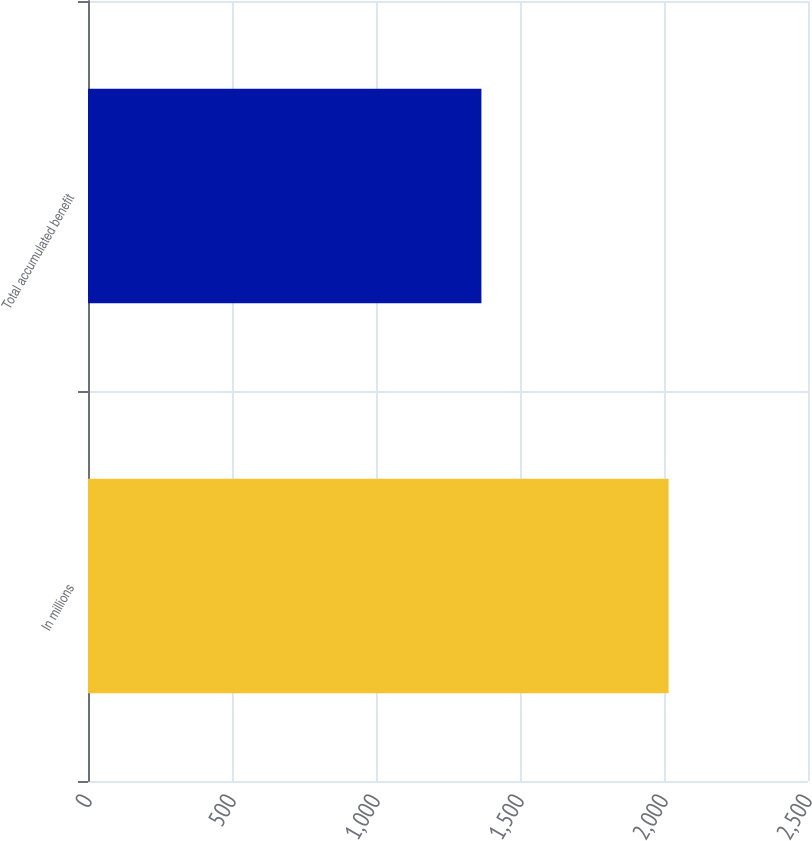<chart> <loc_0><loc_0><loc_500><loc_500><bar_chart><fcel>In millions<fcel>Total accumulated benefit<nl><fcel>2016<fcel>1366<nl></chart> 